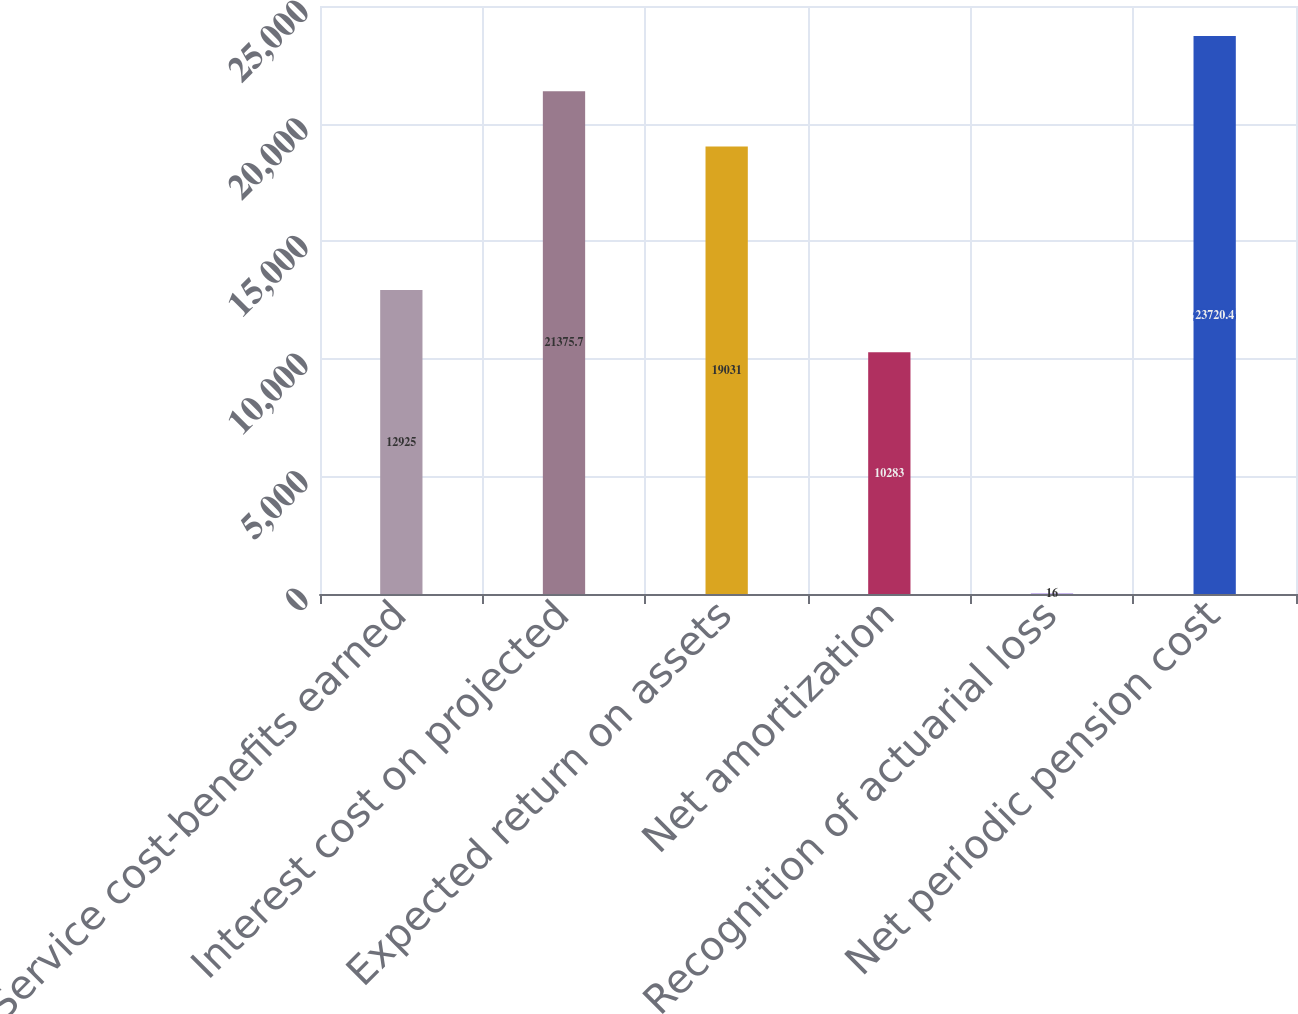Convert chart to OTSL. <chart><loc_0><loc_0><loc_500><loc_500><bar_chart><fcel>Service cost-benefits earned<fcel>Interest cost on projected<fcel>Expected return on assets<fcel>Net amortization<fcel>Recognition of actuarial loss<fcel>Net periodic pension cost<nl><fcel>12925<fcel>21375.7<fcel>19031<fcel>10283<fcel>16<fcel>23720.4<nl></chart> 